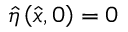Convert formula to latex. <formula><loc_0><loc_0><loc_500><loc_500>\hat { \eta } \left ( \hat { x } , 0 \right ) = 0</formula> 